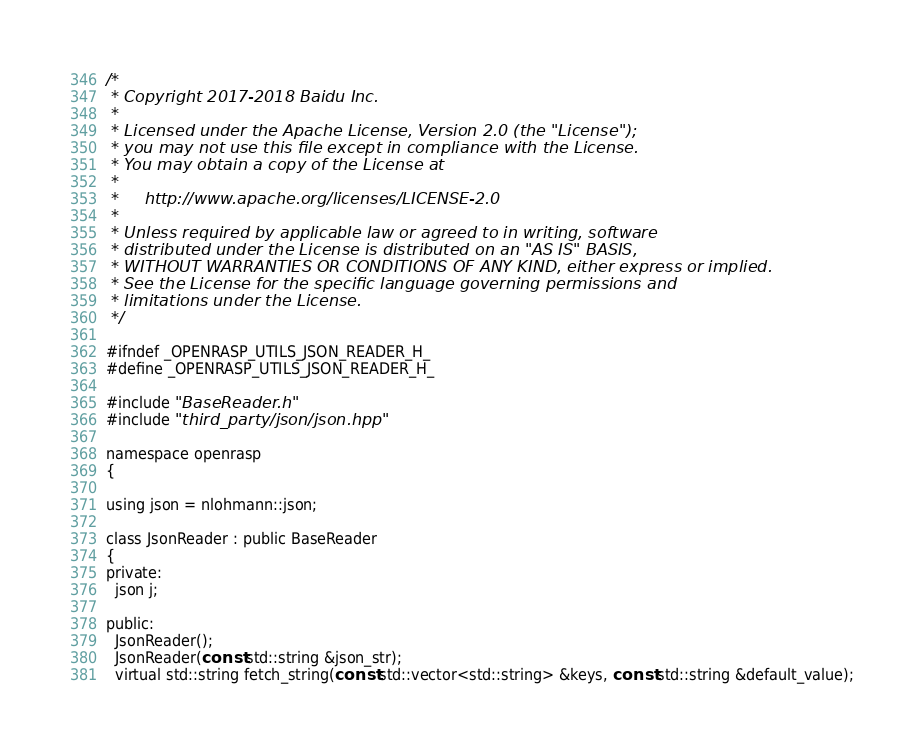Convert code to text. <code><loc_0><loc_0><loc_500><loc_500><_C_>/*
 * Copyright 2017-2018 Baidu Inc.
 *
 * Licensed under the Apache License, Version 2.0 (the "License");
 * you may not use this file except in compliance with the License.
 * You may obtain a copy of the License at
 *
 *     http://www.apache.org/licenses/LICENSE-2.0
 *
 * Unless required by applicable law or agreed to in writing, software
 * distributed under the License is distributed on an "AS IS" BASIS,
 * WITHOUT WARRANTIES OR CONDITIONS OF ANY KIND, either express or implied.
 * See the License for the specific language governing permissions and
 * limitations under the License.
 */

#ifndef _OPENRASP_UTILS_JSON_READER_H_
#define _OPENRASP_UTILS_JSON_READER_H_

#include "BaseReader.h"
#include "third_party/json/json.hpp"

namespace openrasp
{

using json = nlohmann::json;

class JsonReader : public BaseReader
{
private:
  json j;

public:
  JsonReader();
  JsonReader(const std::string &json_str);
  virtual std::string fetch_string(const std::vector<std::string> &keys, const std::string &default_value);</code> 